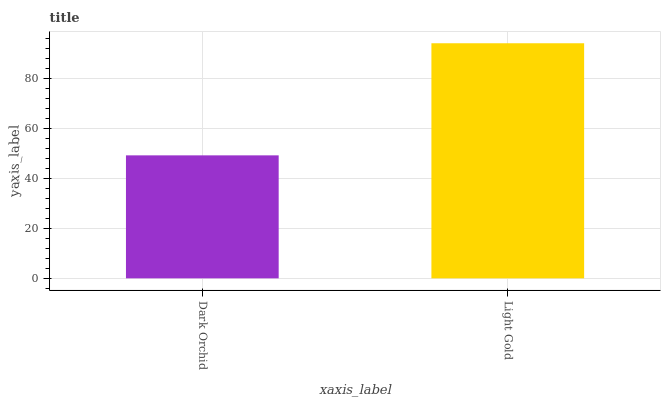Is Dark Orchid the minimum?
Answer yes or no. Yes. Is Light Gold the maximum?
Answer yes or no. Yes. Is Light Gold the minimum?
Answer yes or no. No. Is Light Gold greater than Dark Orchid?
Answer yes or no. Yes. Is Dark Orchid less than Light Gold?
Answer yes or no. Yes. Is Dark Orchid greater than Light Gold?
Answer yes or no. No. Is Light Gold less than Dark Orchid?
Answer yes or no. No. Is Light Gold the high median?
Answer yes or no. Yes. Is Dark Orchid the low median?
Answer yes or no. Yes. Is Dark Orchid the high median?
Answer yes or no. No. Is Light Gold the low median?
Answer yes or no. No. 